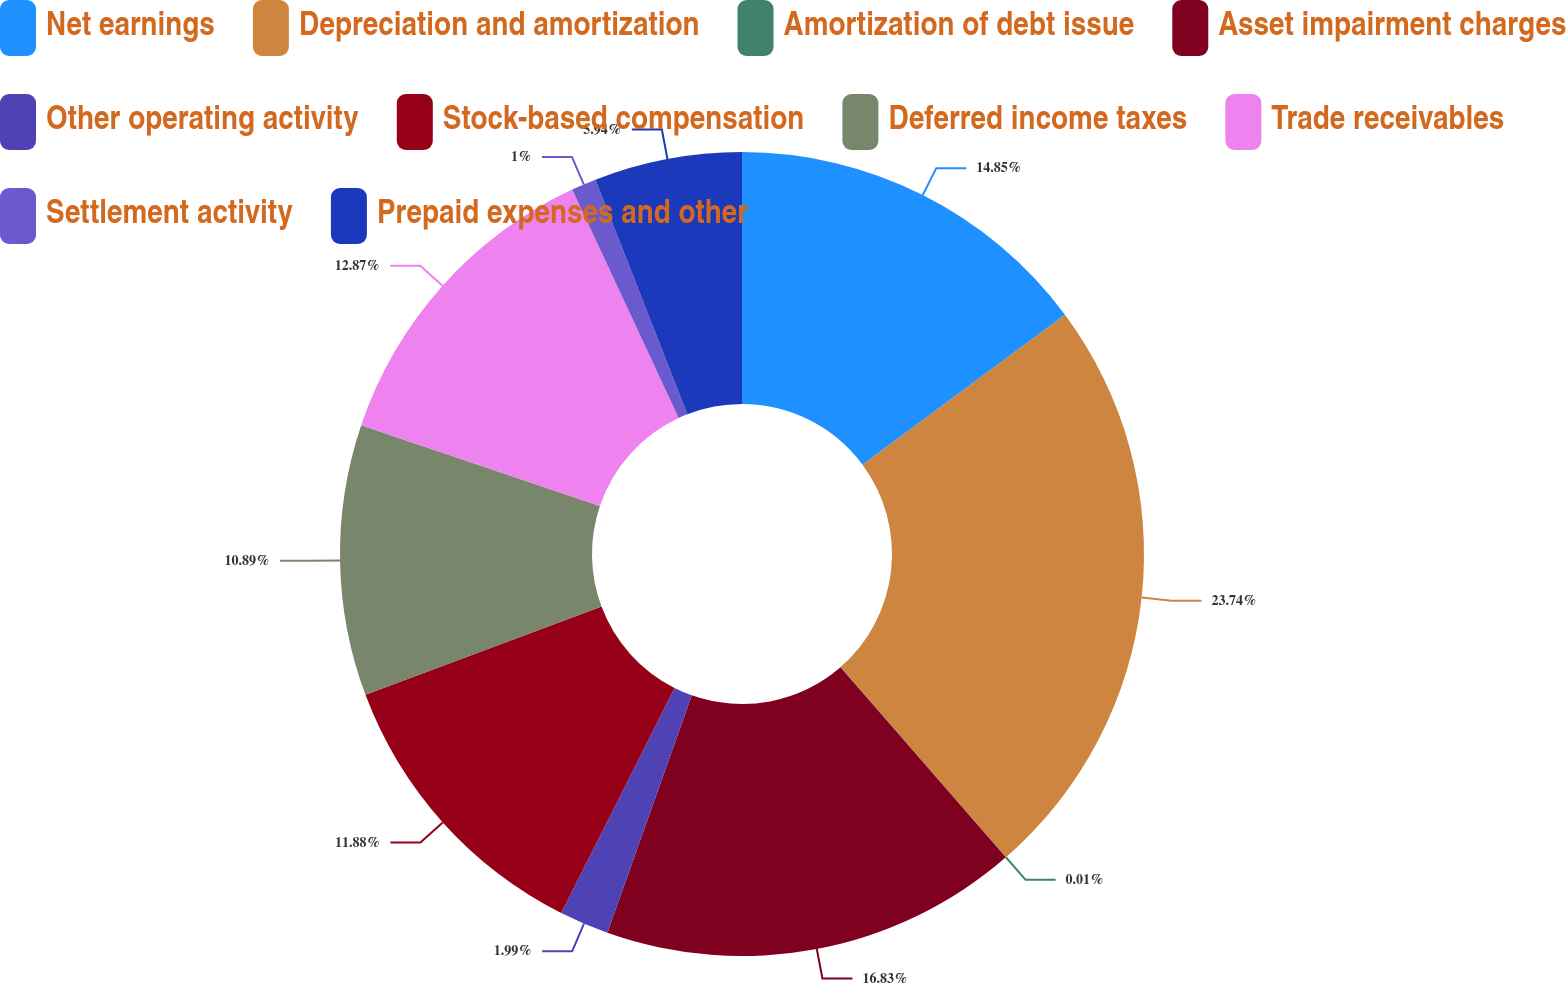<chart> <loc_0><loc_0><loc_500><loc_500><pie_chart><fcel>Net earnings<fcel>Depreciation and amortization<fcel>Amortization of debt issue<fcel>Asset impairment charges<fcel>Other operating activity<fcel>Stock-based compensation<fcel>Deferred income taxes<fcel>Trade receivables<fcel>Settlement activity<fcel>Prepaid expenses and other<nl><fcel>14.85%<fcel>23.75%<fcel>0.01%<fcel>16.83%<fcel>1.99%<fcel>11.88%<fcel>10.89%<fcel>12.87%<fcel>1.0%<fcel>5.94%<nl></chart> 